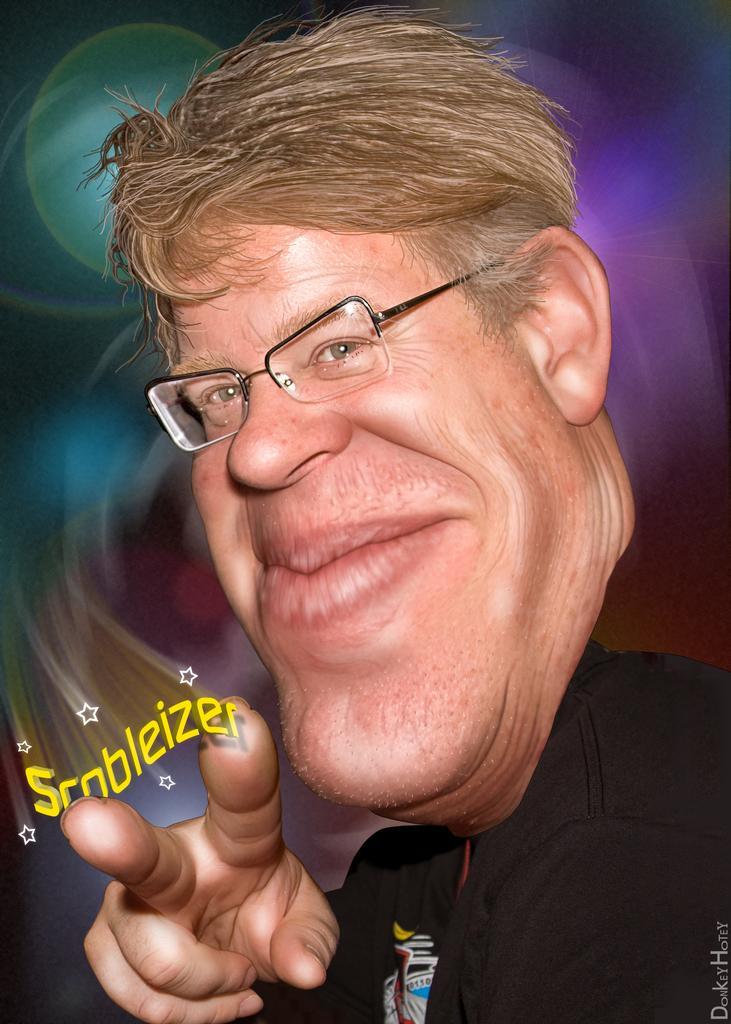In one or two sentences, can you explain what this image depicts? This is an cartoon picture of a man and we see text at the bottom left and bottom right corner and the man wore spectacles on his face. 